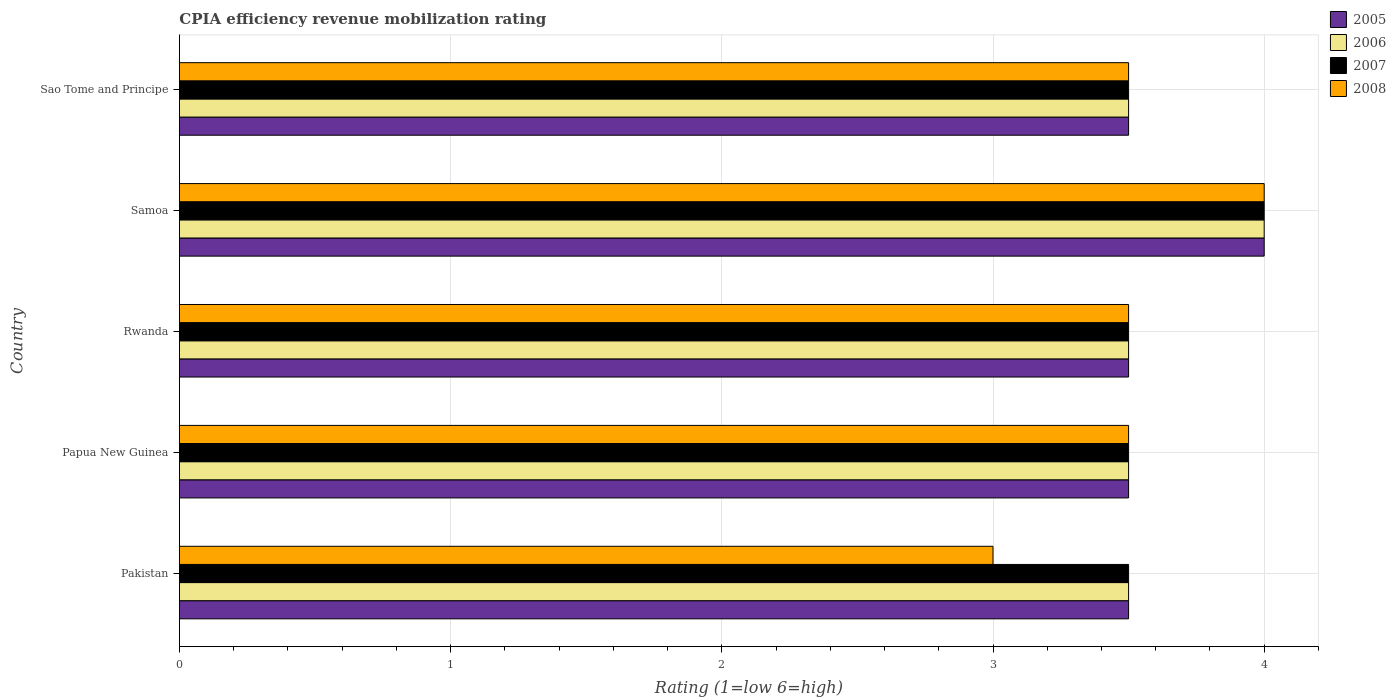How many different coloured bars are there?
Your response must be concise. 4. How many groups of bars are there?
Ensure brevity in your answer.  5. Are the number of bars per tick equal to the number of legend labels?
Your answer should be very brief. Yes. Are the number of bars on each tick of the Y-axis equal?
Your answer should be compact. Yes. How many bars are there on the 4th tick from the top?
Your answer should be very brief. 4. What is the label of the 4th group of bars from the top?
Make the answer very short. Papua New Guinea. What is the CPIA rating in 2005 in Rwanda?
Your answer should be compact. 3.5. Across all countries, what is the maximum CPIA rating in 2005?
Give a very brief answer. 4. In which country was the CPIA rating in 2008 maximum?
Provide a short and direct response. Samoa. What is the total CPIA rating in 2006 in the graph?
Offer a very short reply. 18. What is the difference between the CPIA rating in 2008 in Papua New Guinea and that in Rwanda?
Provide a succinct answer. 0. What is the difference between the CPIA rating in 2006 in Rwanda and the CPIA rating in 2008 in Sao Tome and Principe?
Keep it short and to the point. 0. What is the average CPIA rating in 2008 per country?
Your answer should be very brief. 3.5. What is the ratio of the CPIA rating in 2005 in Papua New Guinea to that in Rwanda?
Provide a short and direct response. 1. Is the sum of the CPIA rating in 2007 in Samoa and Sao Tome and Principe greater than the maximum CPIA rating in 2006 across all countries?
Your response must be concise. Yes. Is it the case that in every country, the sum of the CPIA rating in 2005 and CPIA rating in 2008 is greater than the sum of CPIA rating in 2006 and CPIA rating in 2007?
Your answer should be very brief. No. How many bars are there?
Provide a short and direct response. 20. Are all the bars in the graph horizontal?
Provide a short and direct response. Yes. What is the difference between two consecutive major ticks on the X-axis?
Give a very brief answer. 1. Does the graph contain any zero values?
Offer a terse response. No. Does the graph contain grids?
Offer a terse response. Yes. Where does the legend appear in the graph?
Keep it short and to the point. Top right. How are the legend labels stacked?
Make the answer very short. Vertical. What is the title of the graph?
Provide a succinct answer. CPIA efficiency revenue mobilization rating. What is the label or title of the Y-axis?
Ensure brevity in your answer.  Country. What is the Rating (1=low 6=high) in 2005 in Pakistan?
Make the answer very short. 3.5. What is the Rating (1=low 6=high) of 2007 in Pakistan?
Your response must be concise. 3.5. What is the Rating (1=low 6=high) in 2008 in Pakistan?
Your response must be concise. 3. What is the Rating (1=low 6=high) of 2005 in Papua New Guinea?
Your answer should be compact. 3.5. What is the Rating (1=low 6=high) in 2006 in Papua New Guinea?
Your response must be concise. 3.5. What is the Rating (1=low 6=high) of 2007 in Papua New Guinea?
Ensure brevity in your answer.  3.5. What is the Rating (1=low 6=high) in 2008 in Papua New Guinea?
Keep it short and to the point. 3.5. What is the Rating (1=low 6=high) in 2005 in Rwanda?
Offer a terse response. 3.5. What is the Rating (1=low 6=high) of 2006 in Rwanda?
Offer a terse response. 3.5. What is the Rating (1=low 6=high) in 2007 in Rwanda?
Provide a succinct answer. 3.5. What is the Rating (1=low 6=high) of 2007 in Samoa?
Provide a short and direct response. 4. Across all countries, what is the maximum Rating (1=low 6=high) in 2005?
Your answer should be compact. 4. Across all countries, what is the maximum Rating (1=low 6=high) in 2007?
Your response must be concise. 4. Across all countries, what is the maximum Rating (1=low 6=high) of 2008?
Make the answer very short. 4. Across all countries, what is the minimum Rating (1=low 6=high) in 2005?
Give a very brief answer. 3.5. Across all countries, what is the minimum Rating (1=low 6=high) in 2006?
Provide a short and direct response. 3.5. Across all countries, what is the minimum Rating (1=low 6=high) of 2007?
Your answer should be compact. 3.5. What is the total Rating (1=low 6=high) in 2007 in the graph?
Offer a very short reply. 18. What is the total Rating (1=low 6=high) of 2008 in the graph?
Ensure brevity in your answer.  17.5. What is the difference between the Rating (1=low 6=high) of 2005 in Pakistan and that in Papua New Guinea?
Offer a terse response. 0. What is the difference between the Rating (1=low 6=high) of 2006 in Pakistan and that in Papua New Guinea?
Your answer should be very brief. 0. What is the difference between the Rating (1=low 6=high) of 2005 in Pakistan and that in Rwanda?
Your answer should be very brief. 0. What is the difference between the Rating (1=low 6=high) of 2007 in Pakistan and that in Rwanda?
Make the answer very short. 0. What is the difference between the Rating (1=low 6=high) of 2005 in Pakistan and that in Samoa?
Provide a short and direct response. -0.5. What is the difference between the Rating (1=low 6=high) of 2006 in Pakistan and that in Samoa?
Your answer should be very brief. -0.5. What is the difference between the Rating (1=low 6=high) in 2007 in Pakistan and that in Samoa?
Your answer should be compact. -0.5. What is the difference between the Rating (1=low 6=high) of 2005 in Pakistan and that in Sao Tome and Principe?
Provide a short and direct response. 0. What is the difference between the Rating (1=low 6=high) in 2006 in Pakistan and that in Sao Tome and Principe?
Offer a very short reply. 0. What is the difference between the Rating (1=low 6=high) of 2008 in Pakistan and that in Sao Tome and Principe?
Your answer should be compact. -0.5. What is the difference between the Rating (1=low 6=high) of 2005 in Papua New Guinea and that in Rwanda?
Give a very brief answer. 0. What is the difference between the Rating (1=low 6=high) of 2007 in Papua New Guinea and that in Rwanda?
Keep it short and to the point. 0. What is the difference between the Rating (1=low 6=high) in 2005 in Papua New Guinea and that in Samoa?
Ensure brevity in your answer.  -0.5. What is the difference between the Rating (1=low 6=high) in 2007 in Papua New Guinea and that in Samoa?
Offer a very short reply. -0.5. What is the difference between the Rating (1=low 6=high) in 2008 in Papua New Guinea and that in Samoa?
Provide a short and direct response. -0.5. What is the difference between the Rating (1=low 6=high) in 2008 in Papua New Guinea and that in Sao Tome and Principe?
Provide a short and direct response. 0. What is the difference between the Rating (1=low 6=high) in 2005 in Rwanda and that in Samoa?
Provide a succinct answer. -0.5. What is the difference between the Rating (1=low 6=high) in 2006 in Rwanda and that in Samoa?
Your response must be concise. -0.5. What is the difference between the Rating (1=low 6=high) of 2005 in Samoa and that in Sao Tome and Principe?
Make the answer very short. 0.5. What is the difference between the Rating (1=low 6=high) in 2008 in Samoa and that in Sao Tome and Principe?
Provide a succinct answer. 0.5. What is the difference between the Rating (1=low 6=high) in 2005 in Pakistan and the Rating (1=low 6=high) in 2006 in Papua New Guinea?
Make the answer very short. 0. What is the difference between the Rating (1=low 6=high) in 2005 in Pakistan and the Rating (1=low 6=high) in 2007 in Papua New Guinea?
Provide a short and direct response. 0. What is the difference between the Rating (1=low 6=high) in 2005 in Pakistan and the Rating (1=low 6=high) in 2006 in Rwanda?
Ensure brevity in your answer.  0. What is the difference between the Rating (1=low 6=high) in 2005 in Pakistan and the Rating (1=low 6=high) in 2007 in Rwanda?
Your response must be concise. 0. What is the difference between the Rating (1=low 6=high) in 2005 in Pakistan and the Rating (1=low 6=high) in 2008 in Rwanda?
Provide a short and direct response. 0. What is the difference between the Rating (1=low 6=high) in 2006 in Pakistan and the Rating (1=low 6=high) in 2007 in Rwanda?
Your answer should be very brief. 0. What is the difference between the Rating (1=low 6=high) of 2006 in Pakistan and the Rating (1=low 6=high) of 2008 in Rwanda?
Your answer should be compact. 0. What is the difference between the Rating (1=low 6=high) in 2005 in Pakistan and the Rating (1=low 6=high) in 2006 in Samoa?
Your response must be concise. -0.5. What is the difference between the Rating (1=low 6=high) in 2006 in Pakistan and the Rating (1=low 6=high) in 2008 in Samoa?
Keep it short and to the point. -0.5. What is the difference between the Rating (1=low 6=high) in 2007 in Pakistan and the Rating (1=low 6=high) in 2008 in Samoa?
Make the answer very short. -0.5. What is the difference between the Rating (1=low 6=high) of 2005 in Pakistan and the Rating (1=low 6=high) of 2006 in Sao Tome and Principe?
Offer a terse response. 0. What is the difference between the Rating (1=low 6=high) in 2005 in Pakistan and the Rating (1=low 6=high) in 2007 in Sao Tome and Principe?
Your answer should be very brief. 0. What is the difference between the Rating (1=low 6=high) in 2006 in Pakistan and the Rating (1=low 6=high) in 2008 in Sao Tome and Principe?
Your answer should be very brief. 0. What is the difference between the Rating (1=low 6=high) in 2007 in Pakistan and the Rating (1=low 6=high) in 2008 in Sao Tome and Principe?
Your answer should be very brief. 0. What is the difference between the Rating (1=low 6=high) in 2005 in Papua New Guinea and the Rating (1=low 6=high) in 2008 in Rwanda?
Offer a very short reply. 0. What is the difference between the Rating (1=low 6=high) in 2006 in Papua New Guinea and the Rating (1=low 6=high) in 2008 in Rwanda?
Your answer should be compact. 0. What is the difference between the Rating (1=low 6=high) of 2007 in Papua New Guinea and the Rating (1=low 6=high) of 2008 in Rwanda?
Provide a succinct answer. 0. What is the difference between the Rating (1=low 6=high) in 2005 in Papua New Guinea and the Rating (1=low 6=high) in 2007 in Samoa?
Offer a terse response. -0.5. What is the difference between the Rating (1=low 6=high) in 2005 in Papua New Guinea and the Rating (1=low 6=high) in 2008 in Samoa?
Your response must be concise. -0.5. What is the difference between the Rating (1=low 6=high) in 2006 in Papua New Guinea and the Rating (1=low 6=high) in 2008 in Samoa?
Offer a very short reply. -0.5. What is the difference between the Rating (1=low 6=high) of 2007 in Papua New Guinea and the Rating (1=low 6=high) of 2008 in Samoa?
Your answer should be compact. -0.5. What is the difference between the Rating (1=low 6=high) in 2005 in Papua New Guinea and the Rating (1=low 6=high) in 2006 in Sao Tome and Principe?
Offer a terse response. 0. What is the difference between the Rating (1=low 6=high) in 2005 in Papua New Guinea and the Rating (1=low 6=high) in 2008 in Sao Tome and Principe?
Provide a succinct answer. 0. What is the difference between the Rating (1=low 6=high) in 2005 in Rwanda and the Rating (1=low 6=high) in 2006 in Samoa?
Ensure brevity in your answer.  -0.5. What is the difference between the Rating (1=low 6=high) in 2005 in Rwanda and the Rating (1=low 6=high) in 2007 in Samoa?
Offer a terse response. -0.5. What is the difference between the Rating (1=low 6=high) in 2005 in Rwanda and the Rating (1=low 6=high) in 2008 in Samoa?
Your response must be concise. -0.5. What is the difference between the Rating (1=low 6=high) in 2006 in Rwanda and the Rating (1=low 6=high) in 2007 in Samoa?
Your response must be concise. -0.5. What is the difference between the Rating (1=low 6=high) in 2006 in Rwanda and the Rating (1=low 6=high) in 2008 in Samoa?
Provide a short and direct response. -0.5. What is the difference between the Rating (1=low 6=high) in 2007 in Rwanda and the Rating (1=low 6=high) in 2008 in Samoa?
Offer a terse response. -0.5. What is the difference between the Rating (1=low 6=high) of 2005 in Rwanda and the Rating (1=low 6=high) of 2006 in Sao Tome and Principe?
Ensure brevity in your answer.  0. What is the difference between the Rating (1=low 6=high) in 2005 in Rwanda and the Rating (1=low 6=high) in 2007 in Sao Tome and Principe?
Provide a succinct answer. 0. What is the difference between the Rating (1=low 6=high) of 2005 in Rwanda and the Rating (1=low 6=high) of 2008 in Sao Tome and Principe?
Your answer should be compact. 0. What is the difference between the Rating (1=low 6=high) in 2006 in Rwanda and the Rating (1=low 6=high) in 2008 in Sao Tome and Principe?
Give a very brief answer. 0. What is the difference between the Rating (1=low 6=high) of 2005 in Samoa and the Rating (1=low 6=high) of 2007 in Sao Tome and Principe?
Keep it short and to the point. 0.5. What is the difference between the Rating (1=low 6=high) of 2006 in Samoa and the Rating (1=low 6=high) of 2007 in Sao Tome and Principe?
Your answer should be very brief. 0.5. What is the difference between the Rating (1=low 6=high) in 2006 in Samoa and the Rating (1=low 6=high) in 2008 in Sao Tome and Principe?
Provide a succinct answer. 0.5. What is the average Rating (1=low 6=high) in 2007 per country?
Your answer should be very brief. 3.6. What is the difference between the Rating (1=low 6=high) of 2005 and Rating (1=low 6=high) of 2008 in Pakistan?
Your response must be concise. 0.5. What is the difference between the Rating (1=low 6=high) of 2006 and Rating (1=low 6=high) of 2007 in Pakistan?
Your response must be concise. 0. What is the difference between the Rating (1=low 6=high) in 2005 and Rating (1=low 6=high) in 2006 in Papua New Guinea?
Give a very brief answer. 0. What is the difference between the Rating (1=low 6=high) of 2005 and Rating (1=low 6=high) of 2007 in Papua New Guinea?
Make the answer very short. 0. What is the difference between the Rating (1=low 6=high) of 2006 and Rating (1=low 6=high) of 2007 in Papua New Guinea?
Your response must be concise. 0. What is the difference between the Rating (1=low 6=high) in 2005 and Rating (1=low 6=high) in 2007 in Rwanda?
Keep it short and to the point. 0. What is the difference between the Rating (1=low 6=high) in 2005 and Rating (1=low 6=high) in 2008 in Rwanda?
Ensure brevity in your answer.  0. What is the difference between the Rating (1=low 6=high) in 2005 and Rating (1=low 6=high) in 2006 in Samoa?
Provide a short and direct response. 0. What is the difference between the Rating (1=low 6=high) in 2006 and Rating (1=low 6=high) in 2007 in Samoa?
Your answer should be very brief. 0. What is the difference between the Rating (1=low 6=high) of 2006 and Rating (1=low 6=high) of 2008 in Samoa?
Make the answer very short. 0. What is the difference between the Rating (1=low 6=high) in 2007 and Rating (1=low 6=high) in 2008 in Samoa?
Ensure brevity in your answer.  0. What is the difference between the Rating (1=low 6=high) of 2005 and Rating (1=low 6=high) of 2008 in Sao Tome and Principe?
Your answer should be very brief. 0. What is the difference between the Rating (1=low 6=high) of 2006 and Rating (1=low 6=high) of 2008 in Sao Tome and Principe?
Ensure brevity in your answer.  0. What is the ratio of the Rating (1=low 6=high) in 2007 in Pakistan to that in Papua New Guinea?
Your answer should be very brief. 1. What is the ratio of the Rating (1=low 6=high) in 2008 in Pakistan to that in Papua New Guinea?
Your answer should be very brief. 0.86. What is the ratio of the Rating (1=low 6=high) of 2005 in Pakistan to that in Rwanda?
Make the answer very short. 1. What is the ratio of the Rating (1=low 6=high) in 2006 in Pakistan to that in Sao Tome and Principe?
Your answer should be very brief. 1. What is the ratio of the Rating (1=low 6=high) in 2006 in Papua New Guinea to that in Rwanda?
Your answer should be compact. 1. What is the ratio of the Rating (1=low 6=high) in 2005 in Papua New Guinea to that in Samoa?
Make the answer very short. 0.88. What is the ratio of the Rating (1=low 6=high) in 2006 in Papua New Guinea to that in Samoa?
Your response must be concise. 0.88. What is the ratio of the Rating (1=low 6=high) of 2007 in Papua New Guinea to that in Samoa?
Provide a succinct answer. 0.88. What is the ratio of the Rating (1=low 6=high) of 2008 in Papua New Guinea to that in Samoa?
Your answer should be compact. 0.88. What is the ratio of the Rating (1=low 6=high) of 2005 in Papua New Guinea to that in Sao Tome and Principe?
Your response must be concise. 1. What is the ratio of the Rating (1=low 6=high) in 2007 in Papua New Guinea to that in Sao Tome and Principe?
Your response must be concise. 1. What is the ratio of the Rating (1=low 6=high) of 2005 in Rwanda to that in Samoa?
Your answer should be compact. 0.88. What is the ratio of the Rating (1=low 6=high) in 2008 in Rwanda to that in Samoa?
Your answer should be very brief. 0.88. What is the ratio of the Rating (1=low 6=high) of 2005 in Rwanda to that in Sao Tome and Principe?
Your response must be concise. 1. What is the ratio of the Rating (1=low 6=high) of 2006 in Rwanda to that in Sao Tome and Principe?
Give a very brief answer. 1. What is the ratio of the Rating (1=low 6=high) in 2008 in Rwanda to that in Sao Tome and Principe?
Offer a terse response. 1. What is the ratio of the Rating (1=low 6=high) in 2005 in Samoa to that in Sao Tome and Principe?
Offer a very short reply. 1.14. What is the ratio of the Rating (1=low 6=high) of 2006 in Samoa to that in Sao Tome and Principe?
Give a very brief answer. 1.14. What is the ratio of the Rating (1=low 6=high) in 2008 in Samoa to that in Sao Tome and Principe?
Offer a very short reply. 1.14. What is the difference between the highest and the second highest Rating (1=low 6=high) in 2006?
Provide a short and direct response. 0.5. What is the difference between the highest and the second highest Rating (1=low 6=high) in 2007?
Keep it short and to the point. 0.5. What is the difference between the highest and the lowest Rating (1=low 6=high) of 2007?
Offer a very short reply. 0.5. 